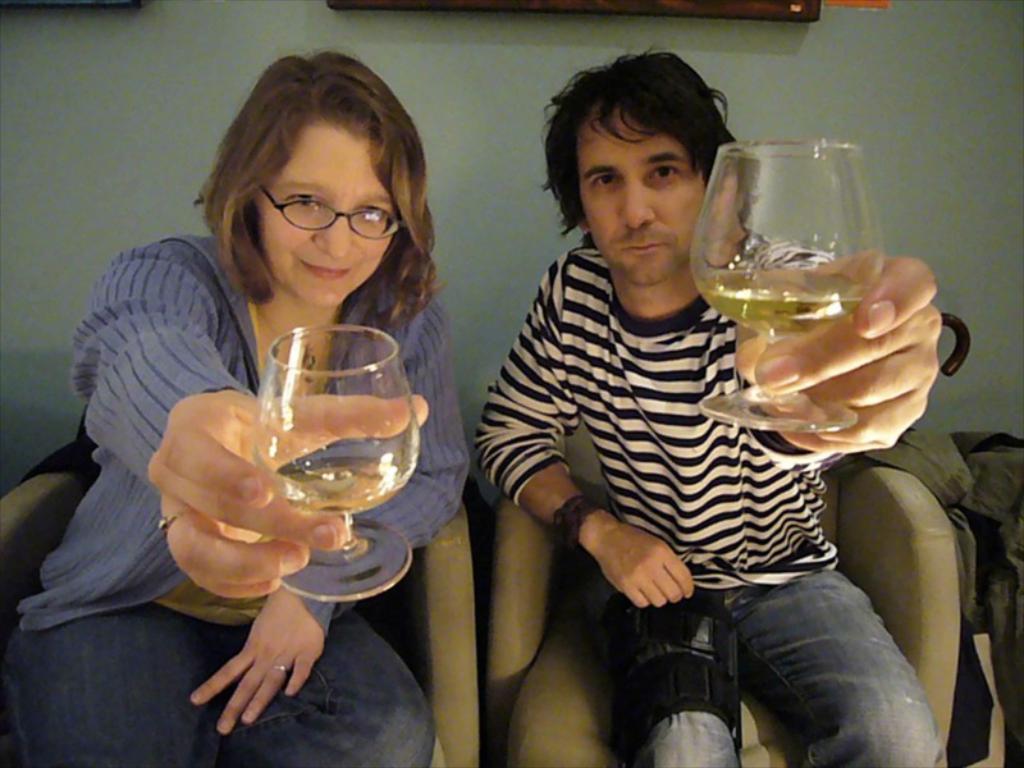Describe this image in one or two sentences. There is a man and woman in the image. They are sitting on the chairs holding a wine glass in their hands with wine in it and smiling. The man is wearing a white T-shirt with black stripes on it and a watch too. The woman is wearing a dress with blue shrug on it. She is wearing spectacles. In the background there is a wall.  